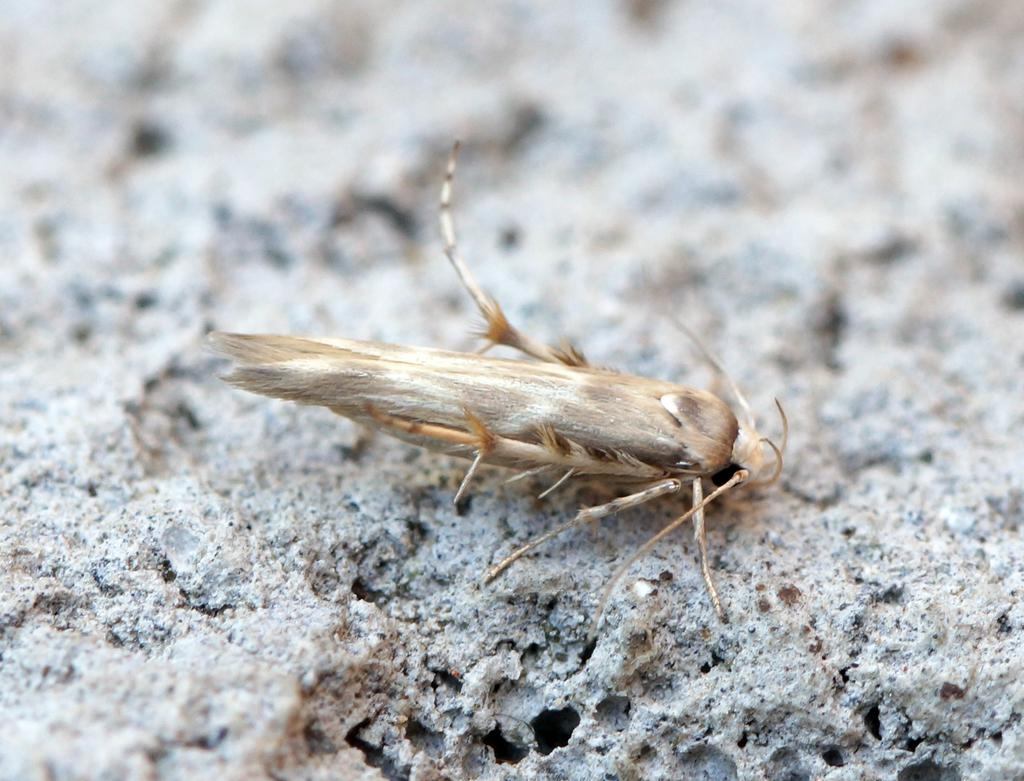What is present on the surface in the image? There is an insect on the surface in the image. Can you describe the background of the image? The background of the image is blurred. What type of bread is being consumed by the insect in the image? There is no bread present in the image, and the insect is not consuming anything. 